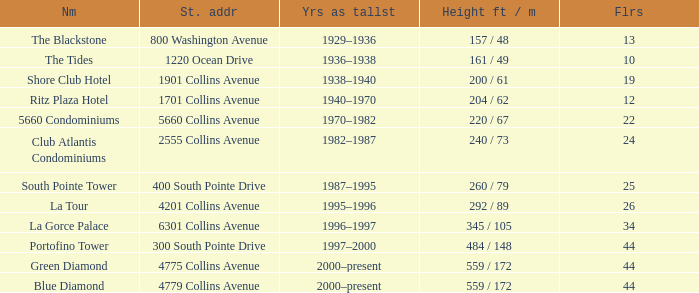How many floors does the Blue Diamond have? 44.0. 